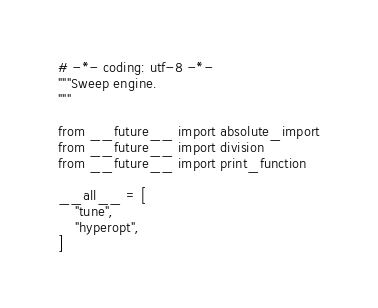Convert code to text. <code><loc_0><loc_0><loc_500><loc_500><_Python_># -*- coding: utf-8 -*-
"""Sweep engine.
"""

from __future__ import absolute_import
from __future__ import division
from __future__ import print_function

__all__ = [
    "tune",
    "hyperopt",
]
</code> 